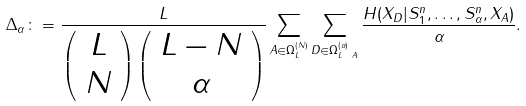Convert formula to latex. <formula><loc_0><loc_0><loc_500><loc_500>\Delta _ { \alpha } \colon = \frac { L } { \left ( \begin{array} { c } L \\ N \end{array} \right ) \left ( \begin{array} { c } L - N \\ \alpha \end{array} \right ) } \sum _ { A \in \Omega _ { L } ^ { ( N ) } } \sum _ { D \in \Omega _ { L \ A } ^ { ( \alpha ) } } \frac { H ( X _ { D } | S _ { 1 } ^ { n } , \dots , S _ { \alpha } ^ { n } , X _ { A } ) } { \alpha } .</formula> 